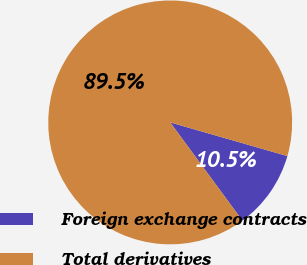Convert chart to OTSL. <chart><loc_0><loc_0><loc_500><loc_500><pie_chart><fcel>Foreign exchange contracts<fcel>Total derivatives<nl><fcel>10.46%<fcel>89.54%<nl></chart> 